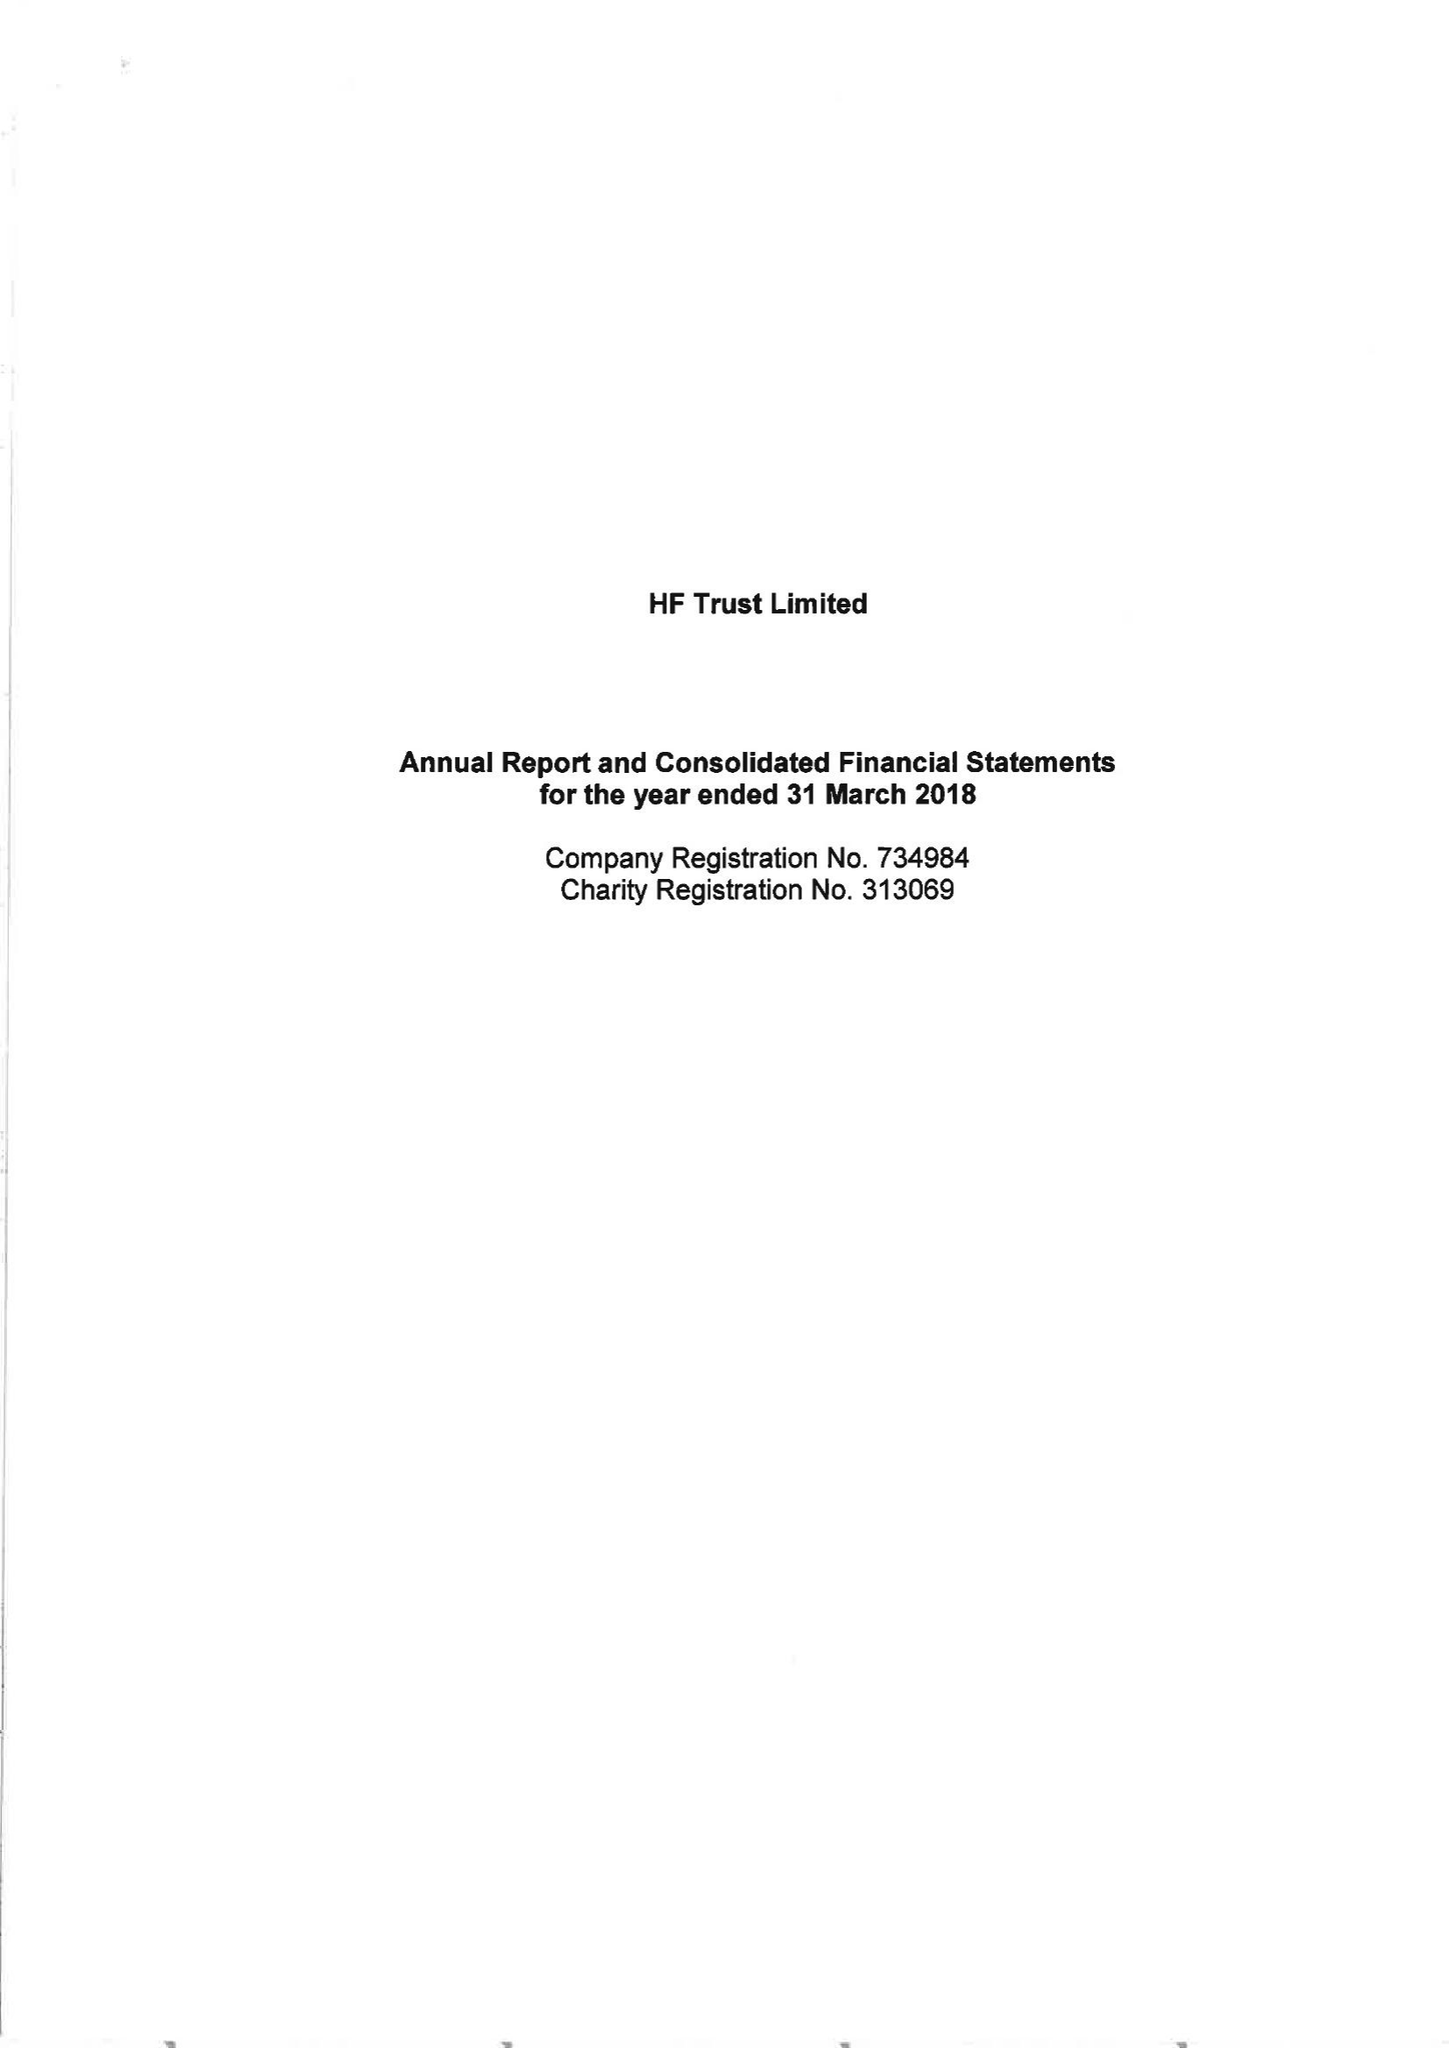What is the value for the address__postcode?
Answer the question using a single word or phrase. BS16 7FL 